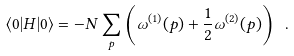Convert formula to latex. <formula><loc_0><loc_0><loc_500><loc_500>\langle 0 | H | 0 \rangle = - N \sum _ { p } \left ( \omega ^ { ( 1 ) } ( p ) + \frac { 1 } { 2 } \omega ^ { ( 2 ) } ( p ) \right ) \ .</formula> 